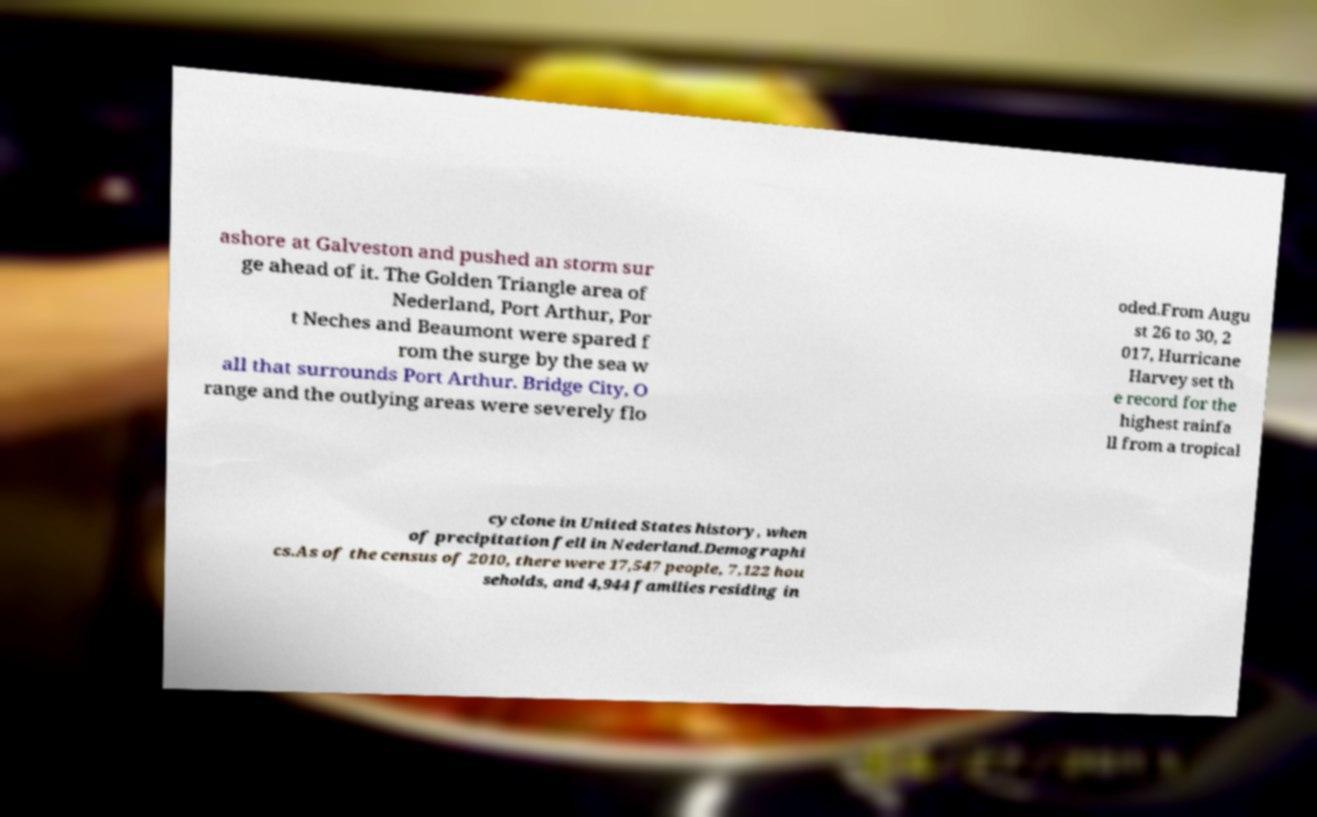Can you accurately transcribe the text from the provided image for me? ashore at Galveston and pushed an storm sur ge ahead of it. The Golden Triangle area of Nederland, Port Arthur, Por t Neches and Beaumont were spared f rom the surge by the sea w all that surrounds Port Arthur. Bridge City, O range and the outlying areas were severely flo oded.From Augu st 26 to 30, 2 017, Hurricane Harvey set th e record for the highest rainfa ll from a tropical cyclone in United States history, when of precipitation fell in Nederland.Demographi cs.As of the census of 2010, there were 17,547 people, 7,122 hou seholds, and 4,944 families residing in 